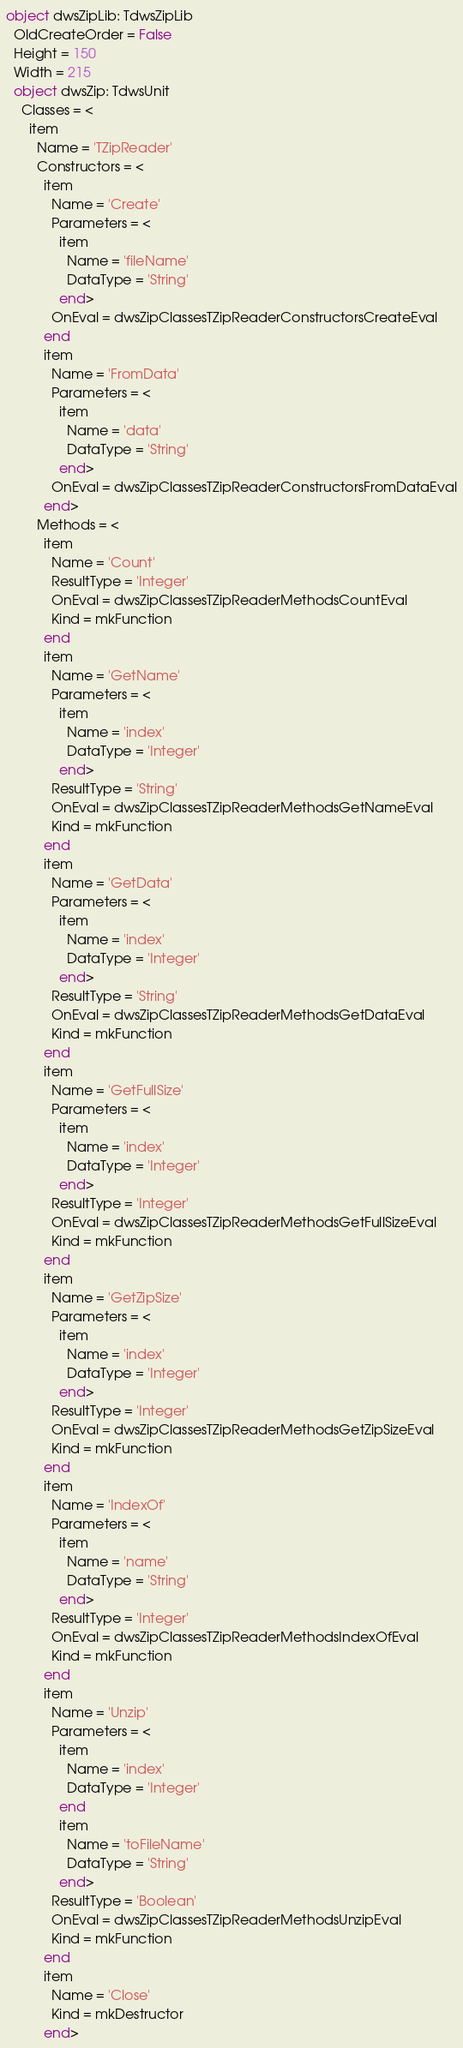<code> <loc_0><loc_0><loc_500><loc_500><_Pascal_>object dwsZipLib: TdwsZipLib
  OldCreateOrder = False
  Height = 150
  Width = 215
  object dwsZip: TdwsUnit
    Classes = <
      item
        Name = 'TZipReader'
        Constructors = <
          item
            Name = 'Create'
            Parameters = <
              item
                Name = 'fileName'
                DataType = 'String'
              end>
            OnEval = dwsZipClassesTZipReaderConstructorsCreateEval
          end
          item
            Name = 'FromData'
            Parameters = <
              item
                Name = 'data'
                DataType = 'String'
              end>
            OnEval = dwsZipClassesTZipReaderConstructorsFromDataEval
          end>
        Methods = <
          item
            Name = 'Count'
            ResultType = 'Integer'
            OnEval = dwsZipClassesTZipReaderMethodsCountEval
            Kind = mkFunction
          end
          item
            Name = 'GetName'
            Parameters = <
              item
                Name = 'index'
                DataType = 'Integer'
              end>
            ResultType = 'String'
            OnEval = dwsZipClassesTZipReaderMethodsGetNameEval
            Kind = mkFunction
          end
          item
            Name = 'GetData'
            Parameters = <
              item
                Name = 'index'
                DataType = 'Integer'
              end>
            ResultType = 'String'
            OnEval = dwsZipClassesTZipReaderMethodsGetDataEval
            Kind = mkFunction
          end
          item
            Name = 'GetFullSize'
            Parameters = <
              item
                Name = 'index'
                DataType = 'Integer'
              end>
            ResultType = 'Integer'
            OnEval = dwsZipClassesTZipReaderMethodsGetFullSizeEval
            Kind = mkFunction
          end
          item
            Name = 'GetZipSize'
            Parameters = <
              item
                Name = 'index'
                DataType = 'Integer'
              end>
            ResultType = 'Integer'
            OnEval = dwsZipClassesTZipReaderMethodsGetZipSizeEval
            Kind = mkFunction
          end
          item
            Name = 'IndexOf'
            Parameters = <
              item
                Name = 'name'
                DataType = 'String'
              end>
            ResultType = 'Integer'
            OnEval = dwsZipClassesTZipReaderMethodsIndexOfEval
            Kind = mkFunction
          end
          item
            Name = 'Unzip'
            Parameters = <
              item
                Name = 'index'
                DataType = 'Integer'
              end
              item
                Name = 'toFileName'
                DataType = 'String'
              end>
            ResultType = 'Boolean'
            OnEval = dwsZipClassesTZipReaderMethodsUnzipEval
            Kind = mkFunction
          end
          item
            Name = 'Close'
            Kind = mkDestructor
          end></code> 